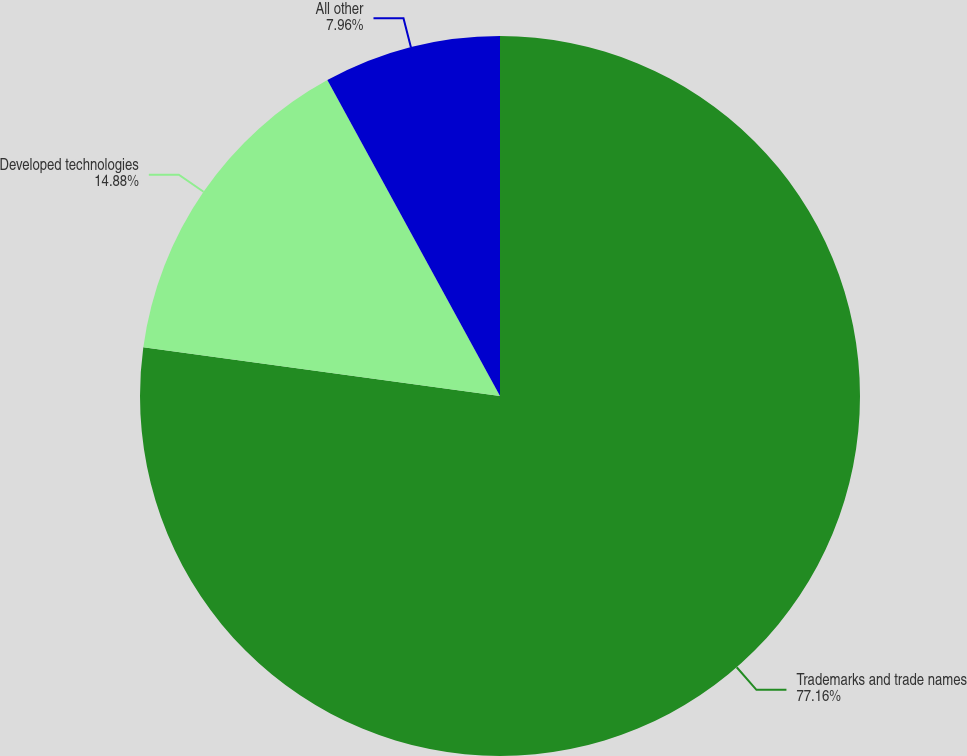Convert chart. <chart><loc_0><loc_0><loc_500><loc_500><pie_chart><fcel>Trademarks and trade names<fcel>Developed technologies<fcel>All other<nl><fcel>77.16%<fcel>14.88%<fcel>7.96%<nl></chart> 